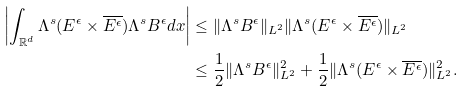Convert formula to latex. <formula><loc_0><loc_0><loc_500><loc_500>\left | \int _ { \mathbb { R } ^ { d } } \Lambda ^ { s } ( E ^ { \epsilon } \times \overline { E ^ { \epsilon } } ) \Lambda ^ { s } B ^ { \epsilon } d x \right | & \leq \| \Lambda ^ { s } B ^ { \epsilon } \| _ { L ^ { 2 } } \| \Lambda ^ { s } ( E ^ { \epsilon } \times \overline { E ^ { \epsilon } } ) \| _ { L ^ { 2 } } \\ & \leq \frac { 1 } { 2 } \| \Lambda ^ { s } B ^ { \epsilon } \| _ { L ^ { 2 } } ^ { 2 } + \frac { 1 } { 2 } \| \Lambda ^ { s } ( E ^ { \epsilon } \times \overline { E ^ { \epsilon } } ) \| _ { L ^ { 2 } } ^ { 2 } .</formula> 